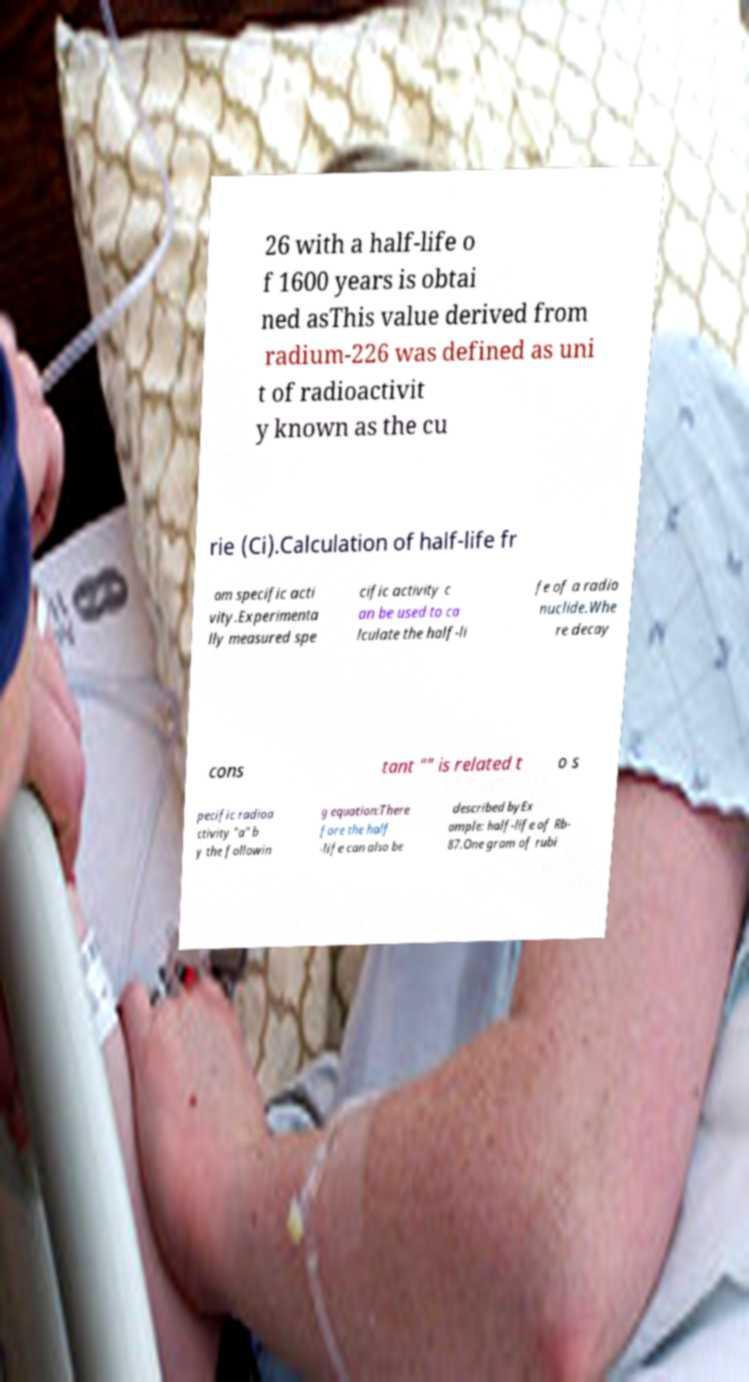Can you read and provide the text displayed in the image?This photo seems to have some interesting text. Can you extract and type it out for me? 26 with a half-life o f 1600 years is obtai ned asThis value derived from radium-226 was defined as uni t of radioactivit y known as the cu rie (Ci).Calculation of half-life fr om specific acti vity.Experimenta lly measured spe cific activity c an be used to ca lculate the half-li fe of a radio nuclide.Whe re decay cons tant "" is related t o s pecific radioa ctivity "a" b y the followin g equation:There fore the half -life can also be described byEx ample: half-life of Rb- 87.One gram of rubi 